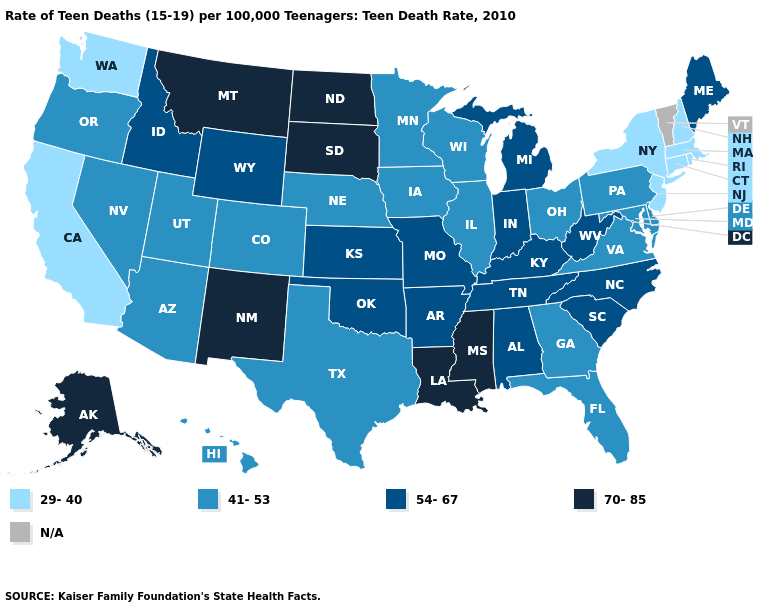Name the states that have a value in the range 41-53?
Concise answer only. Arizona, Colorado, Delaware, Florida, Georgia, Hawaii, Illinois, Iowa, Maryland, Minnesota, Nebraska, Nevada, Ohio, Oregon, Pennsylvania, Texas, Utah, Virginia, Wisconsin. What is the value of Nevada?
Short answer required. 41-53. What is the highest value in the USA?
Be succinct. 70-85. Name the states that have a value in the range 29-40?
Concise answer only. California, Connecticut, Massachusetts, New Hampshire, New Jersey, New York, Rhode Island, Washington. Name the states that have a value in the range 54-67?
Write a very short answer. Alabama, Arkansas, Idaho, Indiana, Kansas, Kentucky, Maine, Michigan, Missouri, North Carolina, Oklahoma, South Carolina, Tennessee, West Virginia, Wyoming. Name the states that have a value in the range 54-67?
Concise answer only. Alabama, Arkansas, Idaho, Indiana, Kansas, Kentucky, Maine, Michigan, Missouri, North Carolina, Oklahoma, South Carolina, Tennessee, West Virginia, Wyoming. Name the states that have a value in the range 70-85?
Write a very short answer. Alaska, Louisiana, Mississippi, Montana, New Mexico, North Dakota, South Dakota. Name the states that have a value in the range 70-85?
Give a very brief answer. Alaska, Louisiana, Mississippi, Montana, New Mexico, North Dakota, South Dakota. Name the states that have a value in the range 54-67?
Write a very short answer. Alabama, Arkansas, Idaho, Indiana, Kansas, Kentucky, Maine, Michigan, Missouri, North Carolina, Oklahoma, South Carolina, Tennessee, West Virginia, Wyoming. Does Wyoming have the lowest value in the USA?
Write a very short answer. No. Name the states that have a value in the range 70-85?
Write a very short answer. Alaska, Louisiana, Mississippi, Montana, New Mexico, North Dakota, South Dakota. What is the lowest value in states that border Iowa?
Concise answer only. 41-53. Name the states that have a value in the range 29-40?
Concise answer only. California, Connecticut, Massachusetts, New Hampshire, New Jersey, New York, Rhode Island, Washington. Among the states that border Wisconsin , does Minnesota have the highest value?
Be succinct. No. 